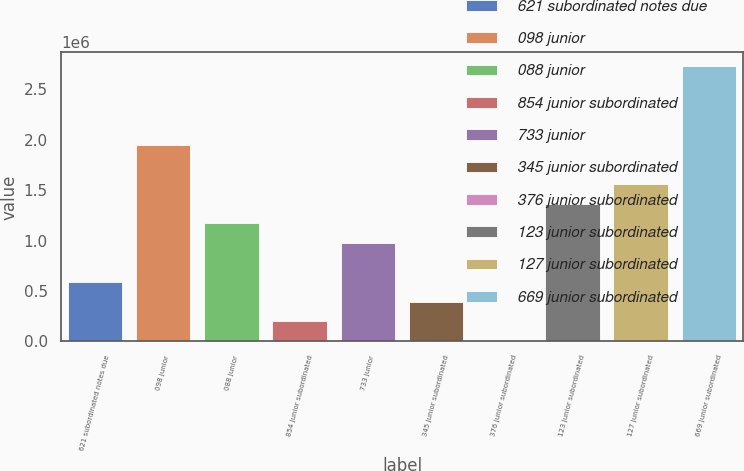<chart> <loc_0><loc_0><loc_500><loc_500><bar_chart><fcel>621 subordinated notes due<fcel>098 junior<fcel>088 junior<fcel>854 junior subordinated<fcel>733 junior<fcel>345 junior subordinated<fcel>376 junior subordinated<fcel>123 junior subordinated<fcel>127 junior subordinated<fcel>669 junior subordinated<nl><fcel>589359<fcel>1.9501e+06<fcel>1.17253e+06<fcel>200577<fcel>978142<fcel>394968<fcel>6186<fcel>1.36692e+06<fcel>1.56131e+06<fcel>2.72766e+06<nl></chart> 